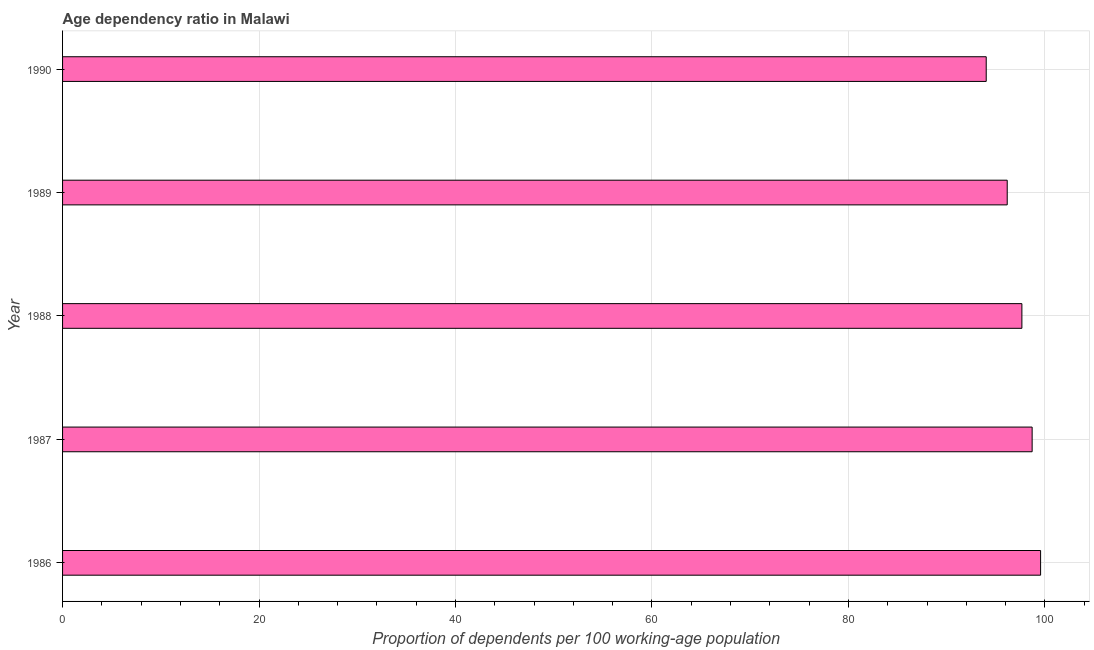What is the title of the graph?
Your response must be concise. Age dependency ratio in Malawi. What is the label or title of the X-axis?
Offer a very short reply. Proportion of dependents per 100 working-age population. What is the label or title of the Y-axis?
Offer a very short reply. Year. What is the age dependency ratio in 1990?
Your response must be concise. 94.03. Across all years, what is the maximum age dependency ratio?
Offer a terse response. 99.56. Across all years, what is the minimum age dependency ratio?
Offer a terse response. 94.03. What is the sum of the age dependency ratio?
Keep it short and to the point. 486.12. What is the difference between the age dependency ratio in 1986 and 1989?
Keep it short and to the point. 3.4. What is the average age dependency ratio per year?
Ensure brevity in your answer.  97.22. What is the median age dependency ratio?
Make the answer very short. 97.66. What is the ratio of the age dependency ratio in 1986 to that in 1989?
Make the answer very short. 1.03. What is the difference between the highest and the second highest age dependency ratio?
Provide a short and direct response. 0.86. What is the difference between the highest and the lowest age dependency ratio?
Make the answer very short. 5.53. How many bars are there?
Ensure brevity in your answer.  5. Are all the bars in the graph horizontal?
Keep it short and to the point. Yes. What is the Proportion of dependents per 100 working-age population in 1986?
Give a very brief answer. 99.56. What is the Proportion of dependents per 100 working-age population in 1987?
Make the answer very short. 98.7. What is the Proportion of dependents per 100 working-age population in 1988?
Provide a short and direct response. 97.66. What is the Proportion of dependents per 100 working-age population in 1989?
Keep it short and to the point. 96.16. What is the Proportion of dependents per 100 working-age population in 1990?
Make the answer very short. 94.03. What is the difference between the Proportion of dependents per 100 working-age population in 1986 and 1987?
Provide a short and direct response. 0.86. What is the difference between the Proportion of dependents per 100 working-age population in 1986 and 1988?
Provide a succinct answer. 1.9. What is the difference between the Proportion of dependents per 100 working-age population in 1986 and 1989?
Keep it short and to the point. 3.4. What is the difference between the Proportion of dependents per 100 working-age population in 1986 and 1990?
Provide a succinct answer. 5.53. What is the difference between the Proportion of dependents per 100 working-age population in 1987 and 1988?
Make the answer very short. 1.04. What is the difference between the Proportion of dependents per 100 working-age population in 1987 and 1989?
Provide a succinct answer. 2.54. What is the difference between the Proportion of dependents per 100 working-age population in 1987 and 1990?
Make the answer very short. 4.67. What is the difference between the Proportion of dependents per 100 working-age population in 1988 and 1989?
Your response must be concise. 1.49. What is the difference between the Proportion of dependents per 100 working-age population in 1988 and 1990?
Your answer should be compact. 3.63. What is the difference between the Proportion of dependents per 100 working-age population in 1989 and 1990?
Provide a succinct answer. 2.14. What is the ratio of the Proportion of dependents per 100 working-age population in 1986 to that in 1987?
Your answer should be compact. 1.01. What is the ratio of the Proportion of dependents per 100 working-age population in 1986 to that in 1989?
Give a very brief answer. 1.03. What is the ratio of the Proportion of dependents per 100 working-age population in 1986 to that in 1990?
Provide a succinct answer. 1.06. What is the ratio of the Proportion of dependents per 100 working-age population in 1987 to that in 1990?
Offer a very short reply. 1.05. What is the ratio of the Proportion of dependents per 100 working-age population in 1988 to that in 1989?
Ensure brevity in your answer.  1.02. What is the ratio of the Proportion of dependents per 100 working-age population in 1988 to that in 1990?
Make the answer very short. 1.04. 